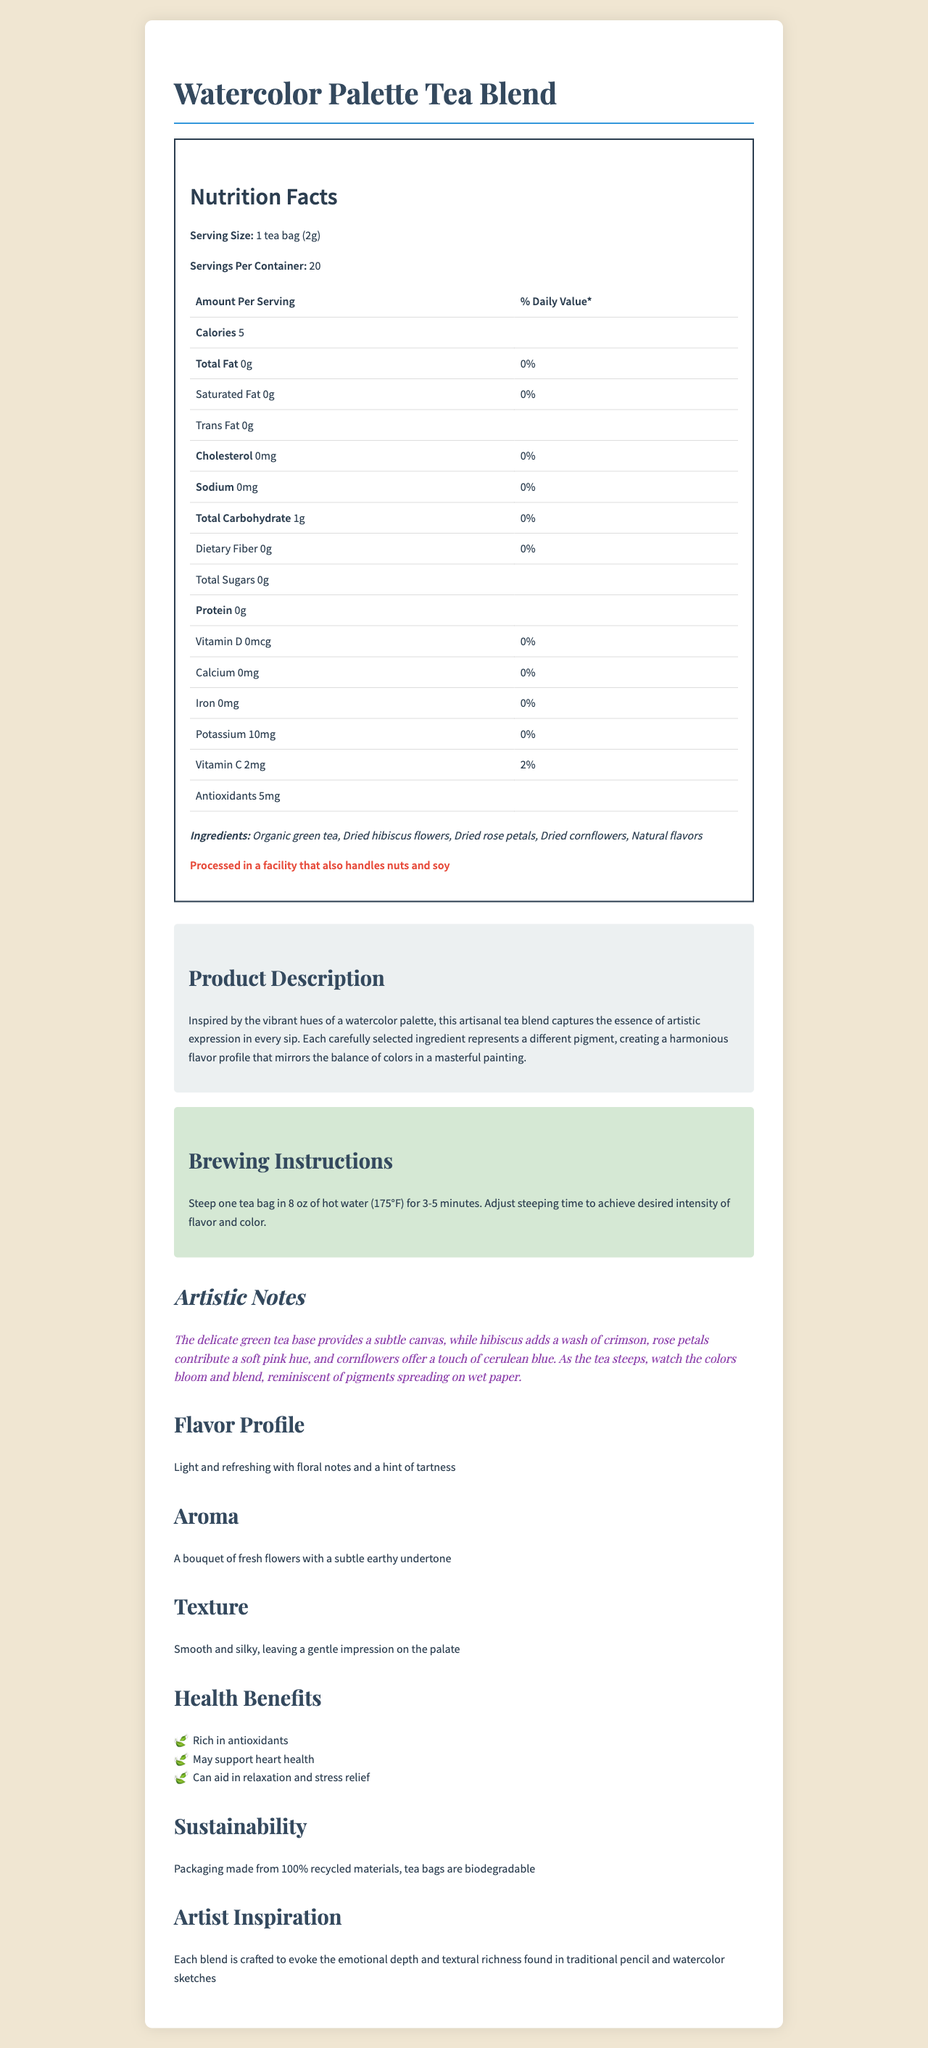what is the serving size of Watercolor Palette Tea Blend? The document specifies the serving size as "1 tea bag (2g)" in the Nutrition Facts section.
Answer: 1 tea bag (2g) how many servings are in one container of the tea blend? The document lists the "Servings Per Container" as 20.
Answer: 20 what is the total carbohydrate content per serving? The table in the Nutrition Facts section states that the total carbohydrate content per serving is 1g.
Answer: 1g can you list the main ingredients of the tea blend? The ingredients section of the Nutrition Facts label lists these ingredients.
Answer: Organic green tea, Dried hibiscus flowers, Dried rose petals, Dried cornflowers, Natural flavors does the tea blend contain any sodium? The Nutrition Facts table shows that the sodium content is 0mg.
Answer: No how does the tea blend support sustainability? The document states "Packaging made from 100% recycled materials, tea bags are biodegradable" under the Sustainability section.
Answer: Packaging made from 100% recycled materials, tea bags are biodegradable which ingredient would add a pink hue to the tea blend? The Artistic Notes mention that "rose petals contribute a soft pink hue."
Answer: Dried rose petals what is the aroma of the tea blend described as? The document describes the aroma as "A bouquet of fresh flowers with a subtle earthy undertone."
Answer: A bouquet of fresh flowers with a subtle earthy undertone what are the health benefits of the tea blend? The Health Benefits section lists these benefits.
Answer: Rich in antioxidants, May support heart health, Can aid in relaxation and stress relief how many calories does one serving of the tea blend contain? The Nutrition Facts state that one serving of the tea blend contains 5 calories.
Answer: 5 which of the following vitamins is provided by the tea blend?
A. Vitamin A
B. Vitamin C
C. Vitamin D
D. Vitamin E The Nutrition Facts section indicates that the tea blend contains Vitamin C, providing 2% of the daily value.
Answer: B. Vitamin C which of the following is NOT an ingredient in the tea blend?
A. Organic green tea
B. Dried blueberries
C. Dried hibiscus flowers
D. Natural flavors The ingredients listed are Organic green tea, Dried hibiscus flowers, Dried rose petals, Dried cornflowers, and Natural flavors. Dried blueberries are not listed.
Answer: B. Dried blueberries is the tea blend suitable for people with nut allergies? The document states that it is "Processed in a facility that also handles nuts and soy."
Answer: No summarize the main idea of the document. The document presents a comprehensive overview of the Watercolor Palette Tea Blend, emphasizing both its nutritional benefits and artistic inspiration. It consists of various sections that explain its ingredients, nutritional content, brewing instructions, artistic notes, flavor profile, aroma, texture, health benefits, and sustainability.
Answer: The document provides detailed information about the Watercolor Palette Tea Blend, including its nutritional facts, ingredients, health benefits, and artistic inspiration. The tea blend is described as an artisanal product with a light and refreshing flavor and a floral aroma, created to evoke the emotional depth and textural richness found in traditional pencil and watercolor sketches. The packaging is sustainable, and the tea blend has several health benefits. what is the specific amount of Vitamin D provided per serving? The Nutrition Facts table lists Vitamin D as 0mcg, but it does not specify any daily value percentage or higher concentration.
Answer: Not enough information 